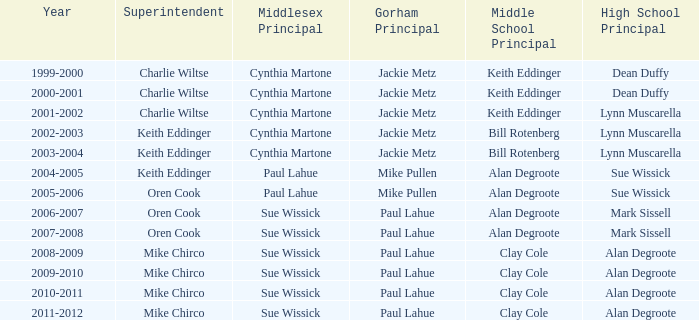Who was the gorham principal in 2010-2011? Paul Lahue. 